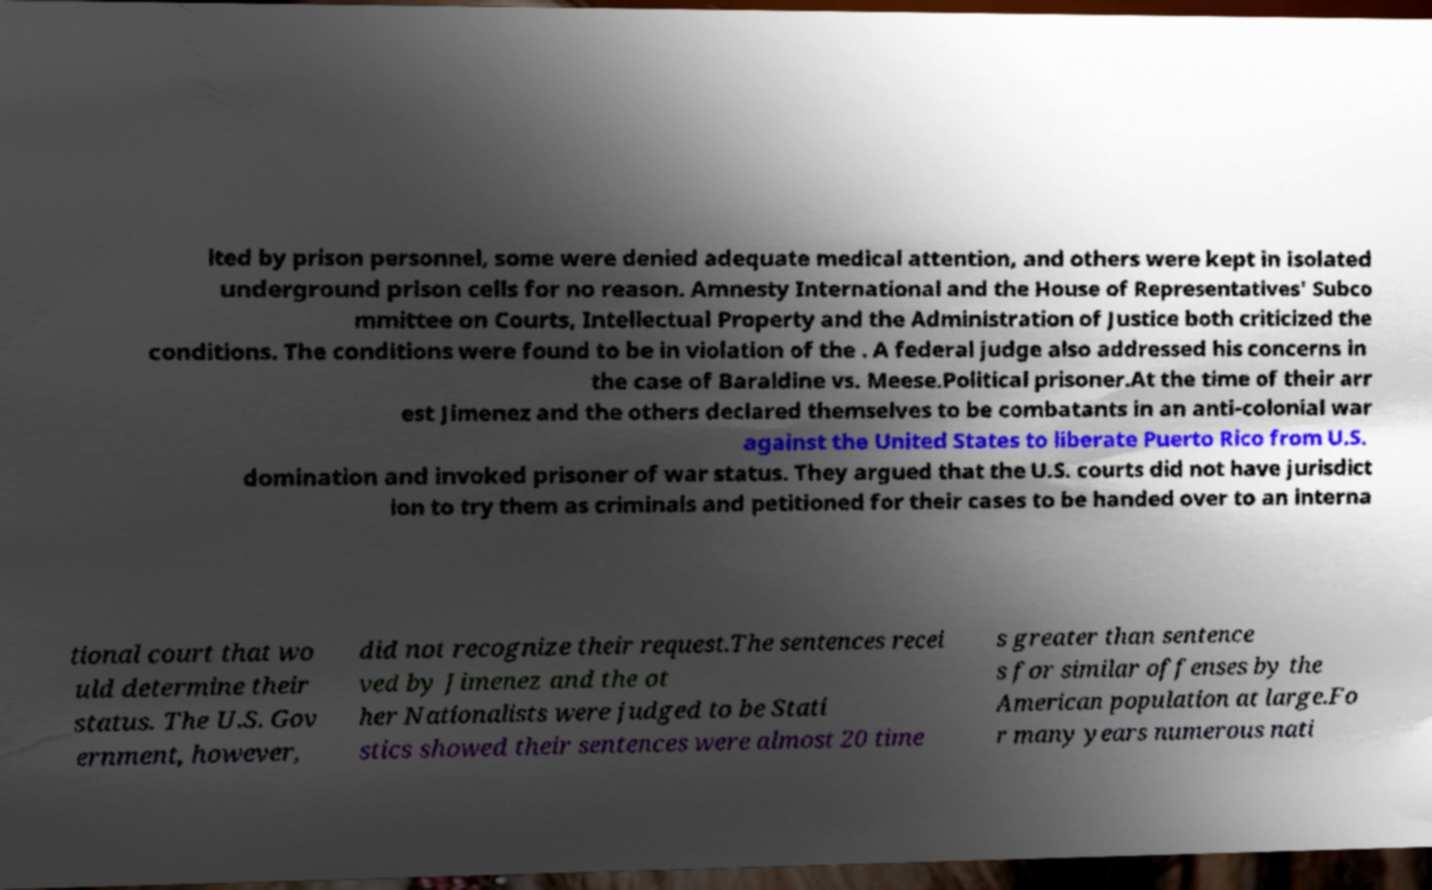Please identify and transcribe the text found in this image. lted by prison personnel, some were denied adequate medical attention, and others were kept in isolated underground prison cells for no reason. Amnesty International and the House of Representatives' Subco mmittee on Courts, Intellectual Property and the Administration of Justice both criticized the conditions. The conditions were found to be in violation of the . A federal judge also addressed his concerns in the case of Baraldine vs. Meese.Political prisoner.At the time of their arr est Jimenez and the others declared themselves to be combatants in an anti-colonial war against the United States to liberate Puerto Rico from U.S. domination and invoked prisoner of war status. They argued that the U.S. courts did not have jurisdict ion to try them as criminals and petitioned for their cases to be handed over to an interna tional court that wo uld determine their status. The U.S. Gov ernment, however, did not recognize their request.The sentences recei ved by Jimenez and the ot her Nationalists were judged to be Stati stics showed their sentences were almost 20 time s greater than sentence s for similar offenses by the American population at large.Fo r many years numerous nati 